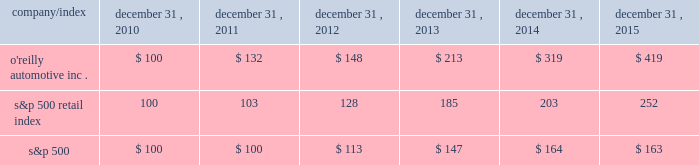Stock performance graph : the graph below shows the cumulative total shareholder return assuming the investment of $ 100 , on december 31 , 2010 , and the reinvestment of dividends thereafter , if any , in the company's common stock versus the standard and poor's s&p 500 retail index ( "s&p 500 retail index" ) and the standard and poor's s&p 500 index ( "s&p 500" ) . .

How much greater was the five year return for the s&p 500 retail index compared to the s&p 500? 
Computations: (252 - 163)
Answer: 89.0. 